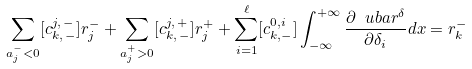Convert formula to latex. <formula><loc_0><loc_0><loc_500><loc_500>\sum _ { a _ { j } ^ { - } < 0 } [ c _ { k , \, - } ^ { j , \, - } ] r _ { j } ^ { - } + \sum _ { a _ { j } ^ { + } > 0 } [ c _ { k , \, - } ^ { j , \, + } ] r _ { j } ^ { + } + \sum _ { i = 1 } ^ { \ell } [ c _ { k , - } ^ { 0 , i } ] \int _ { - \infty } ^ { + \infty } \frac { \partial \ u b a r ^ { \delta } } { \partial \delta _ { i } } d x = r _ { k } ^ { - }</formula> 